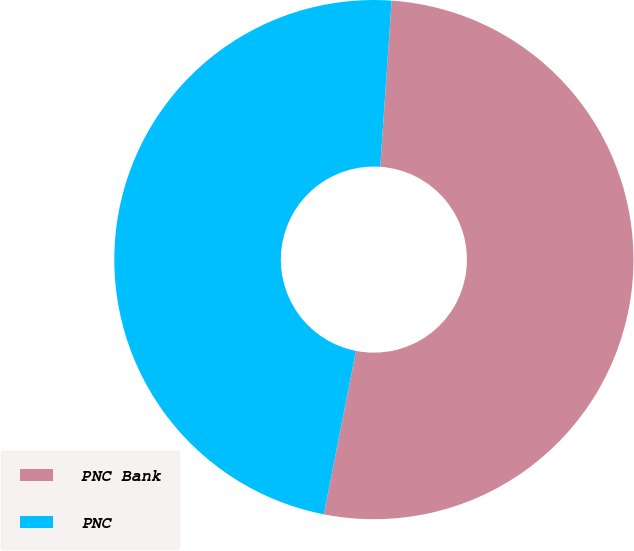Convert chart. <chart><loc_0><loc_0><loc_500><loc_500><pie_chart><fcel>PNC Bank<fcel>PNC<nl><fcel>52.0%<fcel>48.0%<nl></chart> 